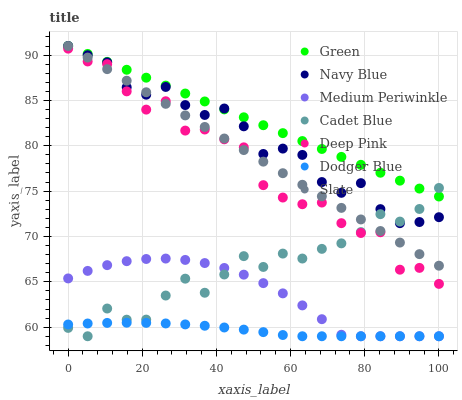Does Dodger Blue have the minimum area under the curve?
Answer yes or no. Yes. Does Green have the maximum area under the curve?
Answer yes or no. Yes. Does Navy Blue have the minimum area under the curve?
Answer yes or no. No. Does Navy Blue have the maximum area under the curve?
Answer yes or no. No. Is Slate the smoothest?
Answer yes or no. Yes. Is Deep Pink the roughest?
Answer yes or no. Yes. Is Navy Blue the smoothest?
Answer yes or no. No. Is Navy Blue the roughest?
Answer yes or no. No. Does Cadet Blue have the lowest value?
Answer yes or no. Yes. Does Navy Blue have the lowest value?
Answer yes or no. No. Does Green have the highest value?
Answer yes or no. Yes. Does Medium Periwinkle have the highest value?
Answer yes or no. No. Is Dodger Blue less than Deep Pink?
Answer yes or no. Yes. Is Green greater than Dodger Blue?
Answer yes or no. Yes. Does Slate intersect Deep Pink?
Answer yes or no. Yes. Is Slate less than Deep Pink?
Answer yes or no. No. Is Slate greater than Deep Pink?
Answer yes or no. No. Does Dodger Blue intersect Deep Pink?
Answer yes or no. No. 